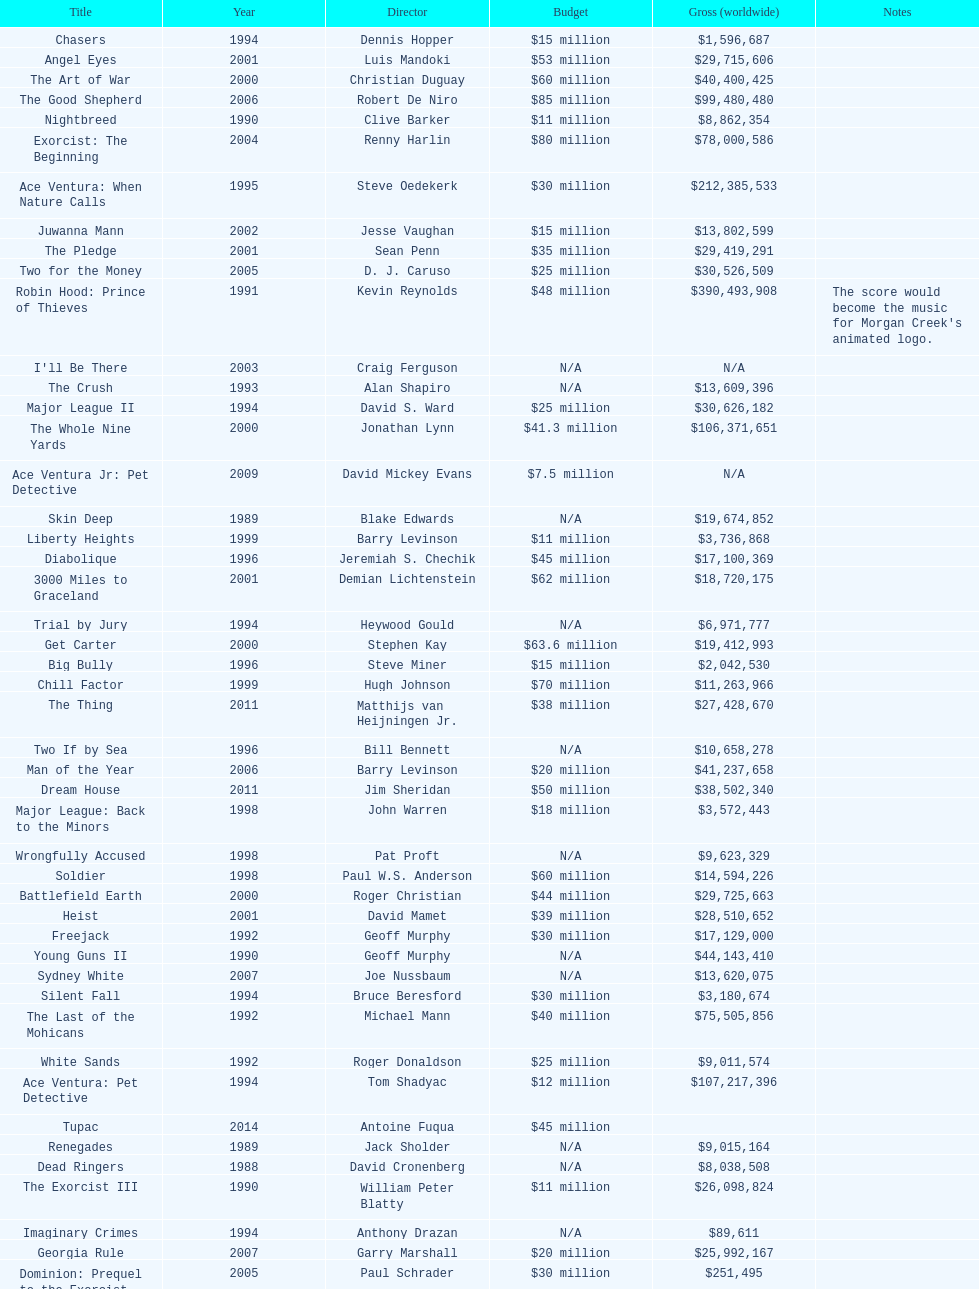Did true romance make more or less money than diabolique? Less. 